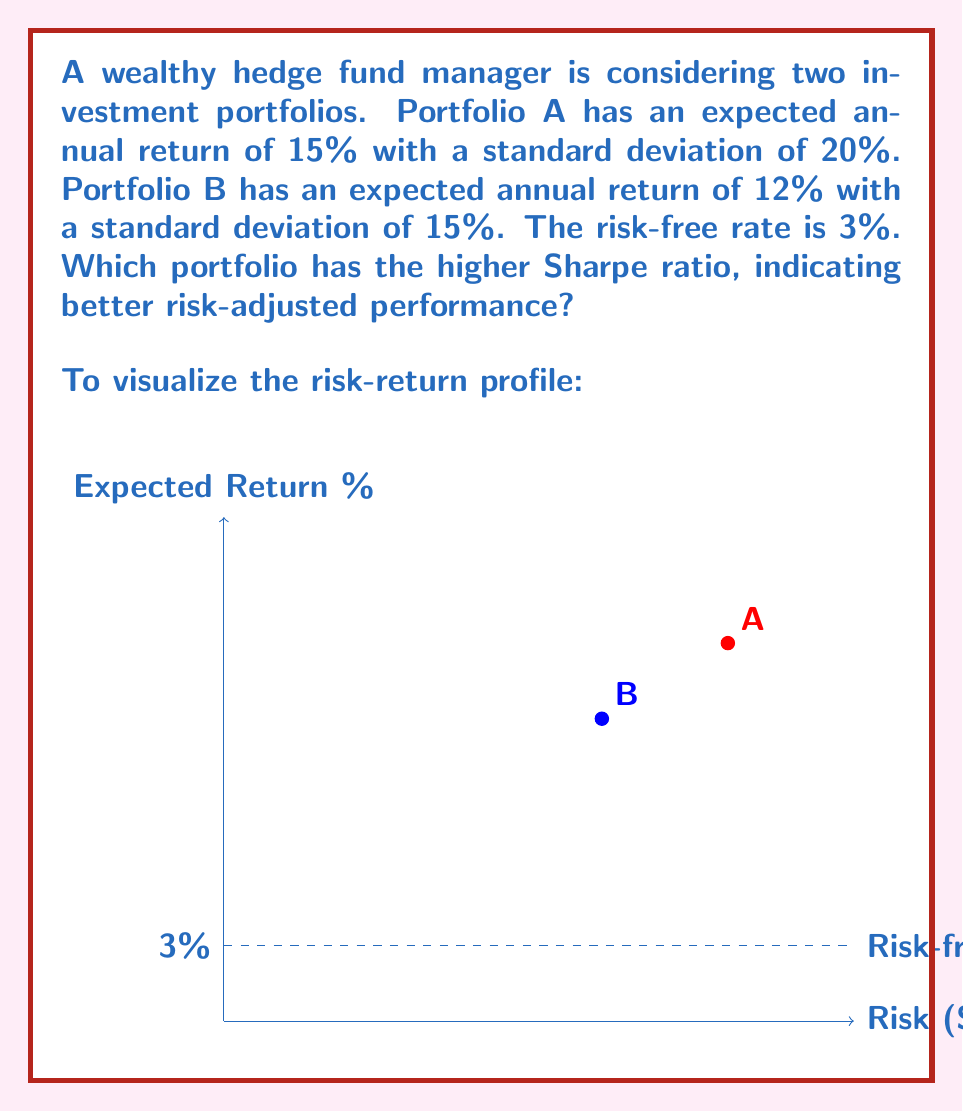Show me your answer to this math problem. To solve this problem, we'll calculate the Sharpe ratio for each portfolio using the formula:

$$ \text{Sharpe Ratio} = \frac{R_p - R_f}{\sigma_p} $$

Where:
$R_p$ = Expected portfolio return
$R_f$ = Risk-free rate
$\sigma_p$ = Portfolio standard deviation

Step 1: Calculate Sharpe ratio for Portfolio A
$$ \text{Sharpe Ratio}_A = \frac{15\% - 3\%}{20\%} = \frac{12\%}{20\%} = 0.60 $$

Step 2: Calculate Sharpe ratio for Portfolio B
$$ \text{Sharpe Ratio}_B = \frac{12\% - 3\%}{15\%} = \frac{9\%}{15\%} = 0.60 $$

Step 3: Compare the Sharpe ratios
Both portfolios have the same Sharpe ratio of 0.60, indicating that they have the same risk-adjusted return despite their different risk-return profiles.
Answer: Both portfolios have equal Sharpe ratios of 0.60. 